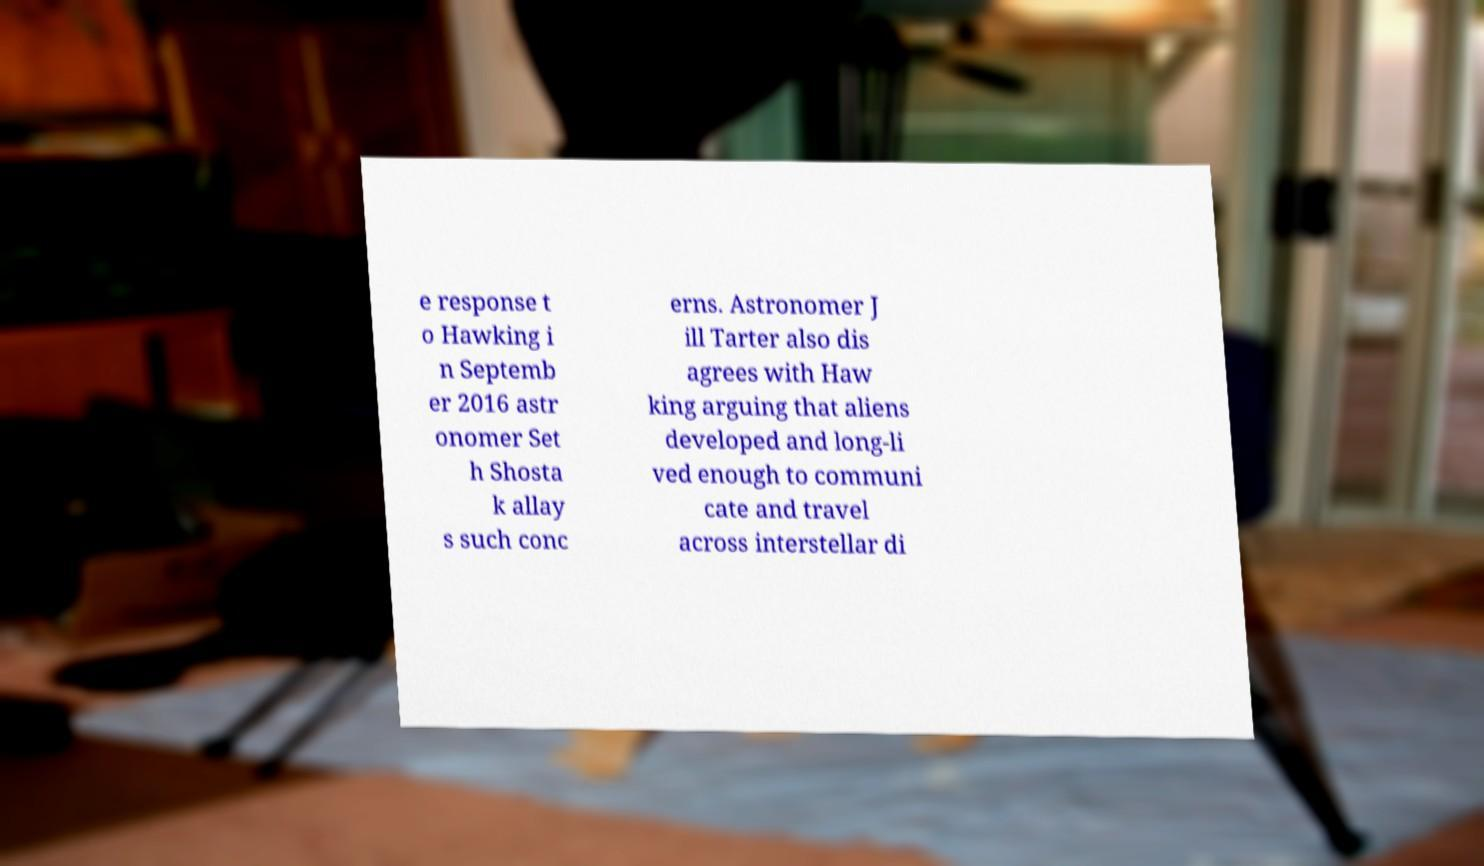I need the written content from this picture converted into text. Can you do that? e response t o Hawking i n Septemb er 2016 astr onomer Set h Shosta k allay s such conc erns. Astronomer J ill Tarter also dis agrees with Haw king arguing that aliens developed and long-li ved enough to communi cate and travel across interstellar di 